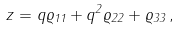Convert formula to latex. <formula><loc_0><loc_0><loc_500><loc_500>z = q \varrho _ { 1 1 } + q ^ { 2 } \varrho _ { 2 2 } + \varrho _ { 3 3 } \, ,</formula> 